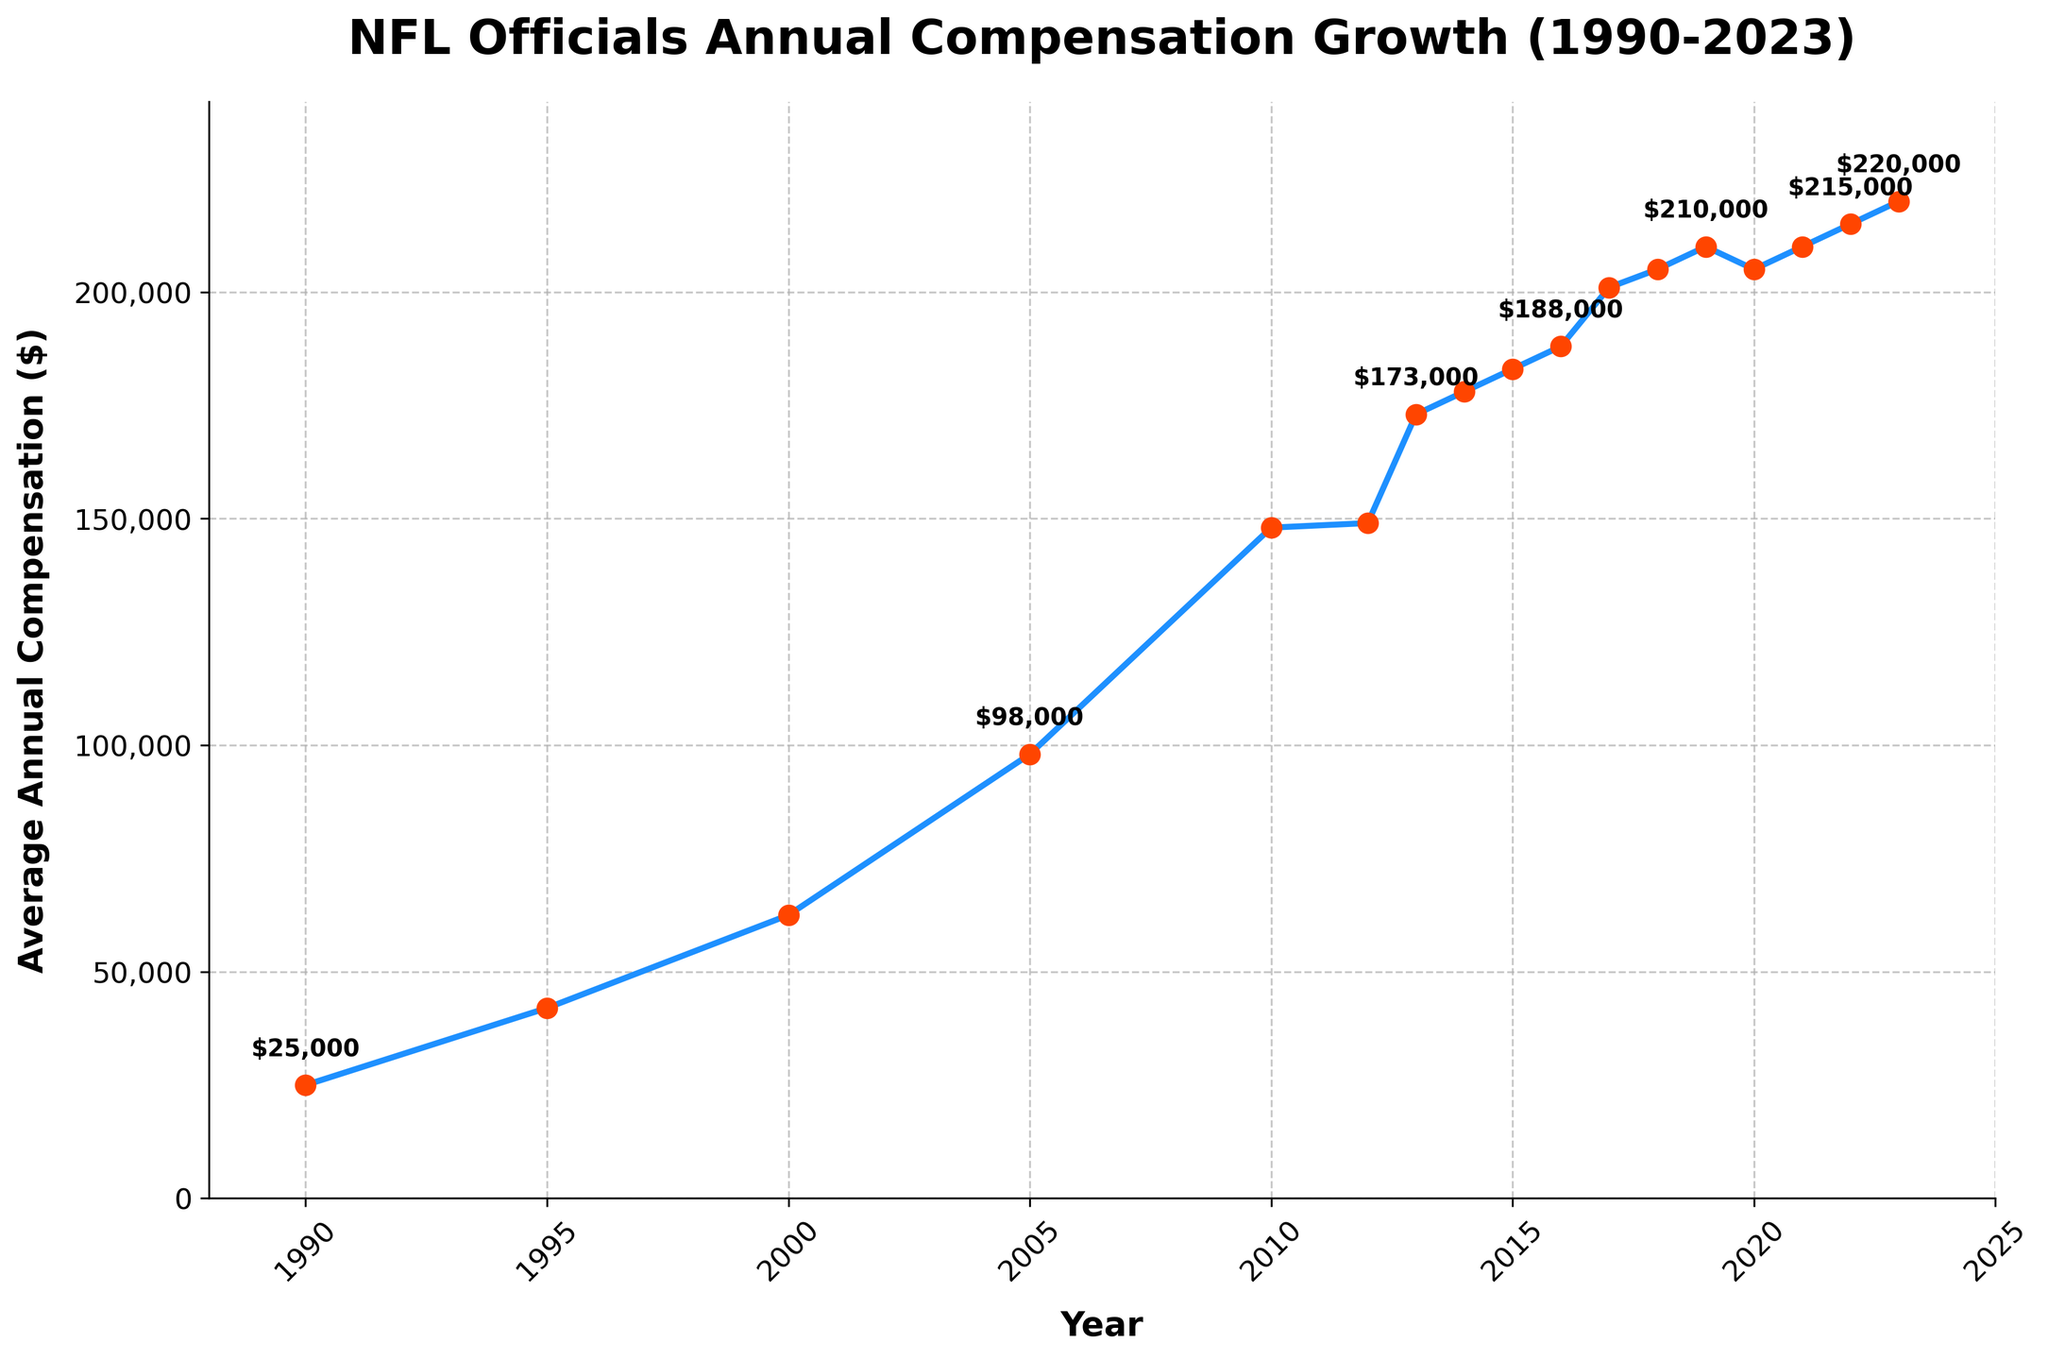What is the highest average annual compensation for NFL officials across the years? The highest annual compensation can be identified by observing the peak value in the plot. Based on the figure, the highest compensation noted is in 2023 at $220,000.
Answer: $220,000 How much did the average annual compensation for NFL officials increase from 1990 to 2023? To determine the increase, subtract the initial value in 1990 from the final value in 2023. The compensation increased from $25,000 in 1990 to $220,000 in 2023, so the increase is $220,000 - $25,000 = $195,000.
Answer: $195,000 In which year did the annual compensation for NFL officials first exceed $100,000? The year the compensation first exceeds $100,000 can be located by observing the point where the y-value crosses $100,000. According to the figure, this occurred in 2005 when the compensation was $98,000 but it surpassed $100,000 between 2005 and 2010. Therefore, the precise first year could be inferred as 2010.
Answer: 2010 Between which years did the NFL officials’ compensation experience the largest increment? To find the largest increment, compare the differences between consecutive years and identify the maximum. By examining the plot, the largest increment appears to be between 2005 ($98,000) and 2010 ($148,000), with a difference of $148,000 - $98,000 = $50,000.
Answer: Between 2005 and 2010 How much did NFL officials' compensation increase between 2012 and 2013? Calculate the difference between 2013 and 2012. The compensation in 2012 was $149,000 and in 2013 it was $173,000. The increase is $173,000 - $149,000 = $24,000.
Answer: $24,000 What pattern do you observe in the compensation trend from 2016 to 2020? Examine the plot from 2016 to 2020 and note the trend. There is a steady increase from 2016 ($188,000) to 2019 ($210,000), followed by a slight dip in 2020 ($205,000).
Answer: Steady increase followed by a slight dip By how much did the compensation change between 2019 and 2020? The change can be found by subtracting the value in 2020 from the value in 2019. $205,000 in 2020 from $210,000 in 2019, resulting in a decrease of $210,000 - $205,000 = $5,000.
Answer: $5,000 decrease 